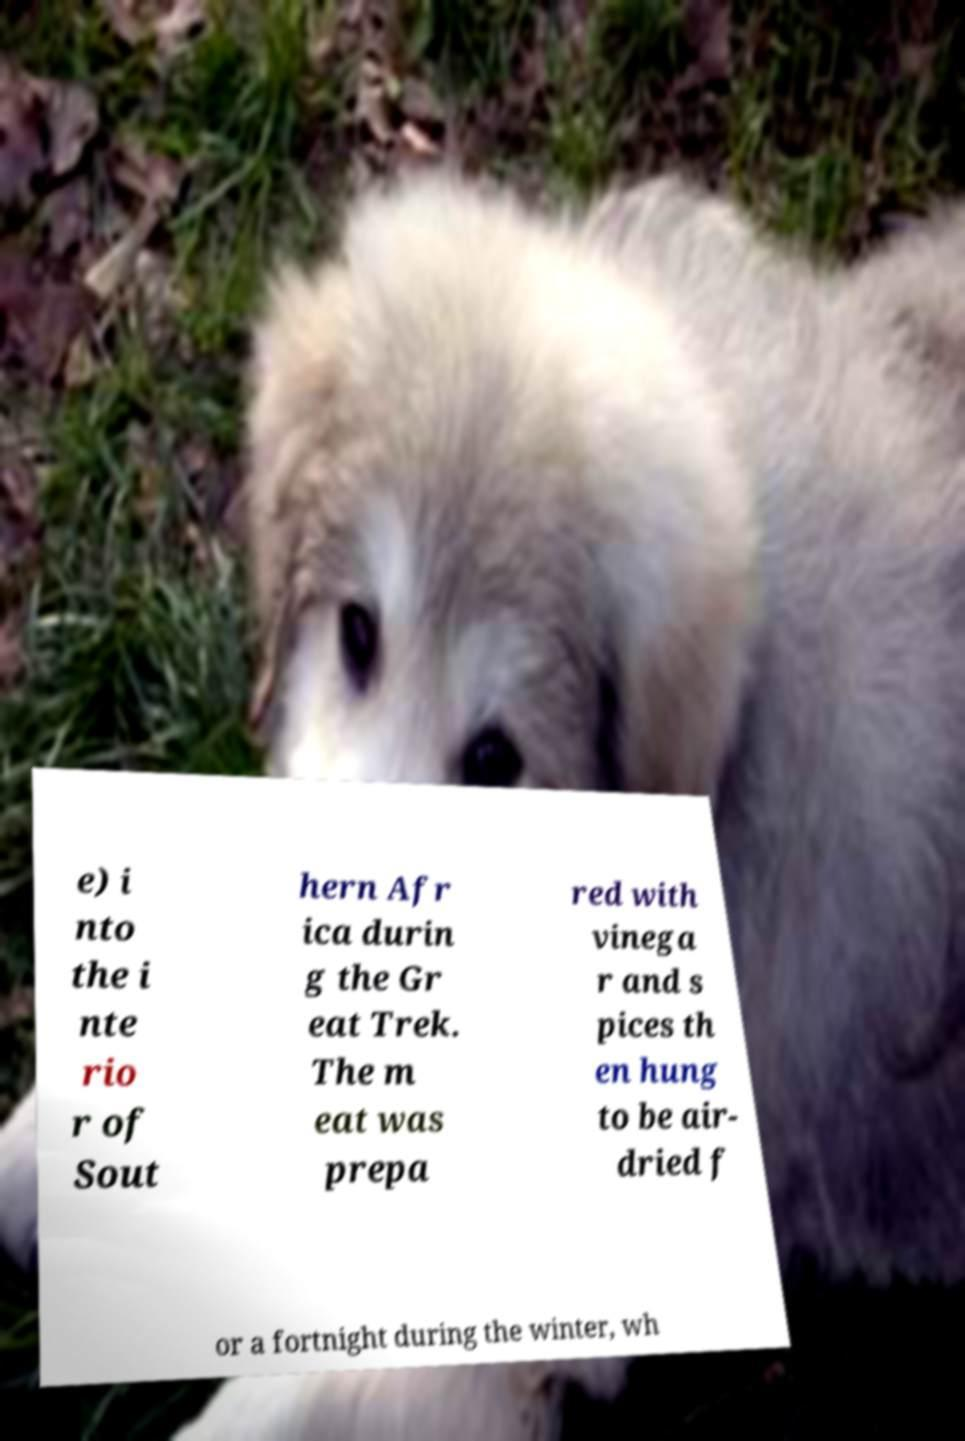Could you assist in decoding the text presented in this image and type it out clearly? e) i nto the i nte rio r of Sout hern Afr ica durin g the Gr eat Trek. The m eat was prepa red with vinega r and s pices th en hung to be air- dried f or a fortnight during the winter, wh 